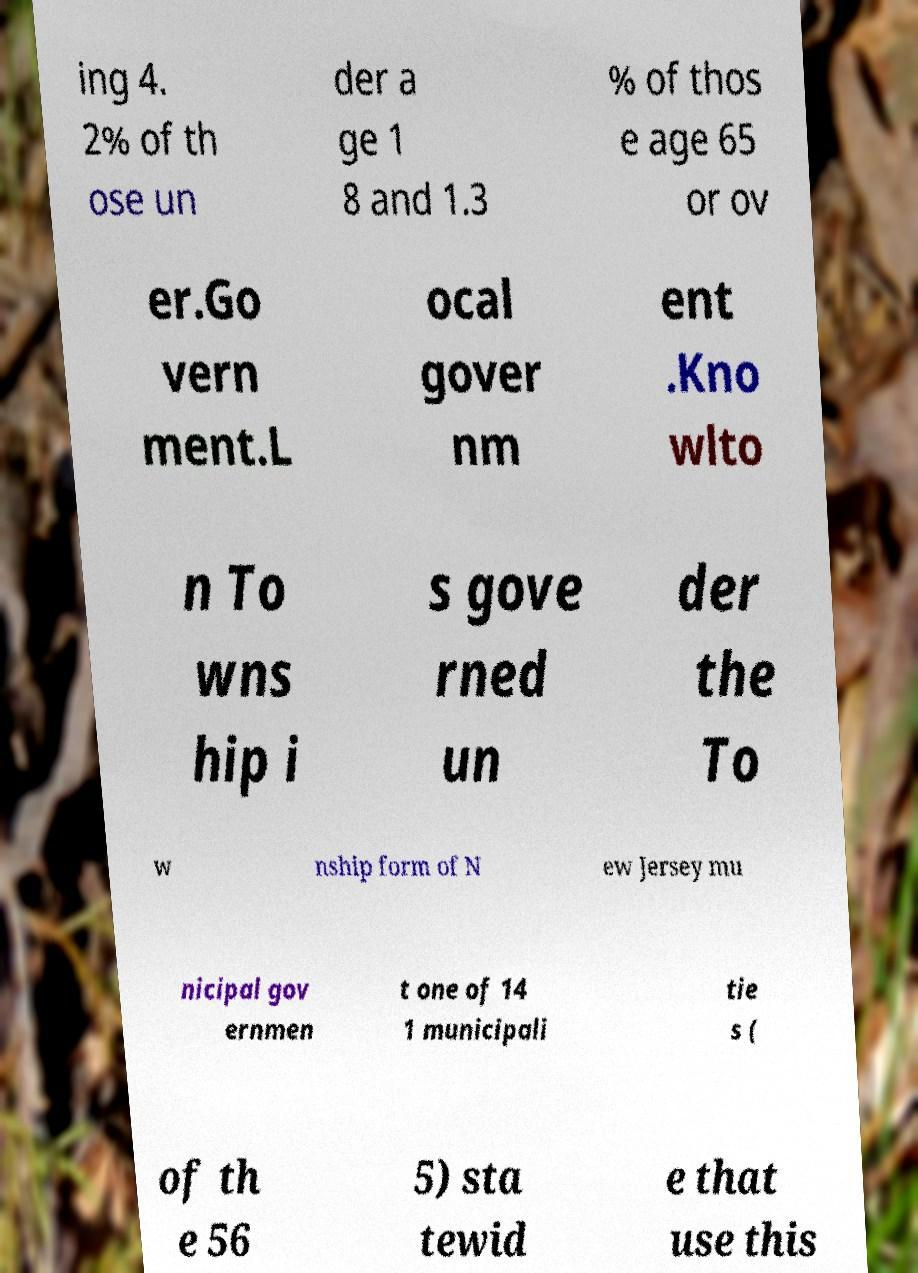Could you extract and type out the text from this image? ing 4. 2% of th ose un der a ge 1 8 and 1.3 % of thos e age 65 or ov er.Go vern ment.L ocal gover nm ent .Kno wlto n To wns hip i s gove rned un der the To w nship form of N ew Jersey mu nicipal gov ernmen t one of 14 1 municipali tie s ( of th e 56 5) sta tewid e that use this 